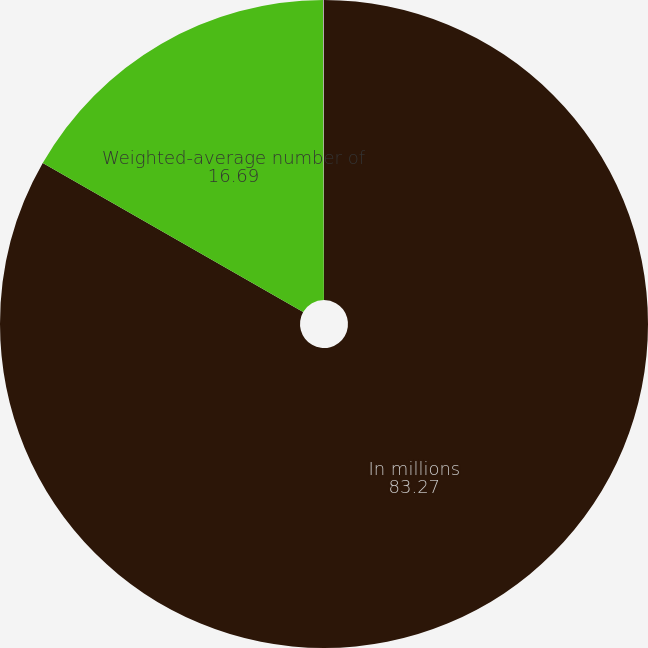<chart> <loc_0><loc_0><loc_500><loc_500><pie_chart><fcel>In millions<fcel>Weighted-average number of<fcel>Shares issuable under<nl><fcel>83.27%<fcel>16.69%<fcel>0.04%<nl></chart> 